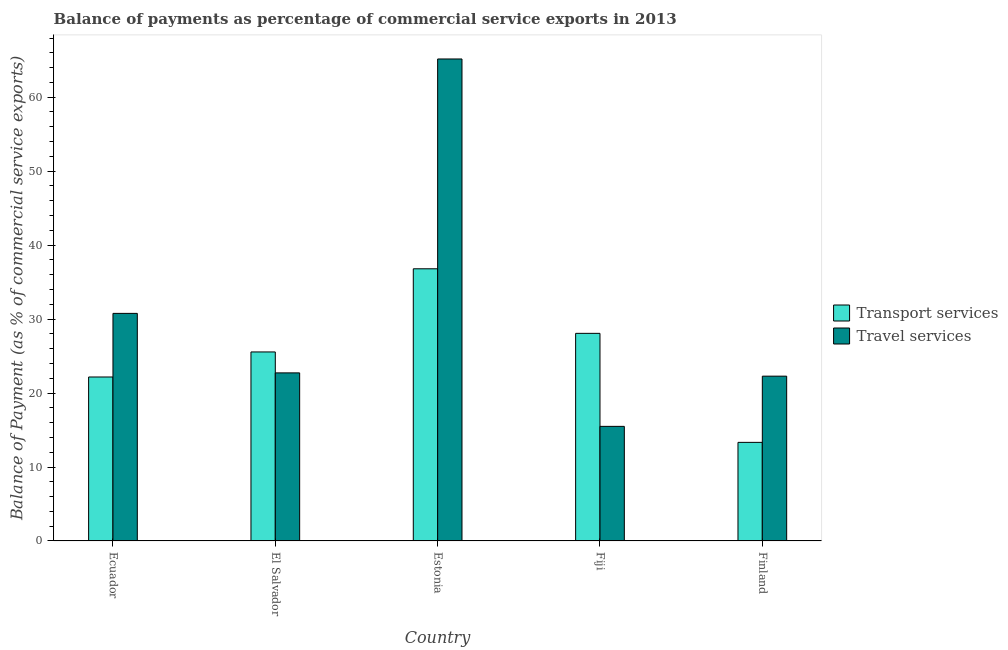How many different coloured bars are there?
Provide a short and direct response. 2. How many groups of bars are there?
Ensure brevity in your answer.  5. What is the label of the 2nd group of bars from the left?
Provide a short and direct response. El Salvador. In how many cases, is the number of bars for a given country not equal to the number of legend labels?
Offer a very short reply. 0. What is the balance of payments of travel services in Ecuador?
Make the answer very short. 30.77. Across all countries, what is the maximum balance of payments of travel services?
Keep it short and to the point. 65.16. Across all countries, what is the minimum balance of payments of travel services?
Your answer should be very brief. 15.49. In which country was the balance of payments of travel services maximum?
Offer a terse response. Estonia. In which country was the balance of payments of travel services minimum?
Your answer should be very brief. Fiji. What is the total balance of payments of transport services in the graph?
Provide a succinct answer. 125.93. What is the difference between the balance of payments of travel services in El Salvador and that in Estonia?
Your answer should be very brief. -42.44. What is the difference between the balance of payments of transport services in El Salvador and the balance of payments of travel services in Finland?
Your answer should be very brief. 3.27. What is the average balance of payments of transport services per country?
Keep it short and to the point. 25.19. What is the difference between the balance of payments of travel services and balance of payments of transport services in Fiji?
Your answer should be very brief. -12.57. In how many countries, is the balance of payments of transport services greater than 46 %?
Make the answer very short. 0. What is the ratio of the balance of payments of travel services in El Salvador to that in Fiji?
Your answer should be very brief. 1.47. What is the difference between the highest and the second highest balance of payments of travel services?
Offer a very short reply. 34.39. What is the difference between the highest and the lowest balance of payments of transport services?
Offer a very short reply. 23.47. In how many countries, is the balance of payments of transport services greater than the average balance of payments of transport services taken over all countries?
Give a very brief answer. 3. Is the sum of the balance of payments of travel services in Estonia and Finland greater than the maximum balance of payments of transport services across all countries?
Provide a succinct answer. Yes. What does the 1st bar from the left in Estonia represents?
Your answer should be compact. Transport services. What does the 1st bar from the right in Estonia represents?
Ensure brevity in your answer.  Travel services. How many bars are there?
Ensure brevity in your answer.  10. Are all the bars in the graph horizontal?
Ensure brevity in your answer.  No. Does the graph contain grids?
Offer a terse response. No. Where does the legend appear in the graph?
Provide a succinct answer. Center right. How many legend labels are there?
Ensure brevity in your answer.  2. How are the legend labels stacked?
Provide a succinct answer. Vertical. What is the title of the graph?
Offer a terse response. Balance of payments as percentage of commercial service exports in 2013. Does "Commercial bank branches" appear as one of the legend labels in the graph?
Keep it short and to the point. No. What is the label or title of the X-axis?
Ensure brevity in your answer.  Country. What is the label or title of the Y-axis?
Give a very brief answer. Balance of Payment (as % of commercial service exports). What is the Balance of Payment (as % of commercial service exports) in Transport services in Ecuador?
Offer a terse response. 22.17. What is the Balance of Payment (as % of commercial service exports) in Travel services in Ecuador?
Your answer should be very brief. 30.77. What is the Balance of Payment (as % of commercial service exports) of Transport services in El Salvador?
Offer a terse response. 25.56. What is the Balance of Payment (as % of commercial service exports) in Travel services in El Salvador?
Your answer should be compact. 22.73. What is the Balance of Payment (as % of commercial service exports) of Transport services in Estonia?
Your answer should be very brief. 36.8. What is the Balance of Payment (as % of commercial service exports) in Travel services in Estonia?
Keep it short and to the point. 65.16. What is the Balance of Payment (as % of commercial service exports) of Transport services in Fiji?
Your response must be concise. 28.07. What is the Balance of Payment (as % of commercial service exports) in Travel services in Fiji?
Your answer should be compact. 15.49. What is the Balance of Payment (as % of commercial service exports) of Transport services in Finland?
Ensure brevity in your answer.  13.33. What is the Balance of Payment (as % of commercial service exports) in Travel services in Finland?
Provide a short and direct response. 22.28. Across all countries, what is the maximum Balance of Payment (as % of commercial service exports) of Transport services?
Keep it short and to the point. 36.8. Across all countries, what is the maximum Balance of Payment (as % of commercial service exports) of Travel services?
Your response must be concise. 65.16. Across all countries, what is the minimum Balance of Payment (as % of commercial service exports) in Transport services?
Make the answer very short. 13.33. Across all countries, what is the minimum Balance of Payment (as % of commercial service exports) in Travel services?
Make the answer very short. 15.49. What is the total Balance of Payment (as % of commercial service exports) of Transport services in the graph?
Your answer should be very brief. 125.93. What is the total Balance of Payment (as % of commercial service exports) in Travel services in the graph?
Provide a short and direct response. 156.44. What is the difference between the Balance of Payment (as % of commercial service exports) in Transport services in Ecuador and that in El Salvador?
Provide a succinct answer. -3.39. What is the difference between the Balance of Payment (as % of commercial service exports) of Travel services in Ecuador and that in El Salvador?
Offer a terse response. 8.04. What is the difference between the Balance of Payment (as % of commercial service exports) in Transport services in Ecuador and that in Estonia?
Your answer should be very brief. -14.63. What is the difference between the Balance of Payment (as % of commercial service exports) in Travel services in Ecuador and that in Estonia?
Give a very brief answer. -34.39. What is the difference between the Balance of Payment (as % of commercial service exports) in Transport services in Ecuador and that in Fiji?
Offer a very short reply. -5.9. What is the difference between the Balance of Payment (as % of commercial service exports) of Travel services in Ecuador and that in Fiji?
Give a very brief answer. 15.28. What is the difference between the Balance of Payment (as % of commercial service exports) in Transport services in Ecuador and that in Finland?
Your response must be concise. 8.84. What is the difference between the Balance of Payment (as % of commercial service exports) of Travel services in Ecuador and that in Finland?
Your answer should be compact. 8.49. What is the difference between the Balance of Payment (as % of commercial service exports) in Transport services in El Salvador and that in Estonia?
Your answer should be very brief. -11.24. What is the difference between the Balance of Payment (as % of commercial service exports) of Travel services in El Salvador and that in Estonia?
Give a very brief answer. -42.44. What is the difference between the Balance of Payment (as % of commercial service exports) in Transport services in El Salvador and that in Fiji?
Your answer should be very brief. -2.51. What is the difference between the Balance of Payment (as % of commercial service exports) in Travel services in El Salvador and that in Fiji?
Keep it short and to the point. 7.23. What is the difference between the Balance of Payment (as % of commercial service exports) in Transport services in El Salvador and that in Finland?
Offer a terse response. 12.22. What is the difference between the Balance of Payment (as % of commercial service exports) in Travel services in El Salvador and that in Finland?
Provide a short and direct response. 0.44. What is the difference between the Balance of Payment (as % of commercial service exports) of Transport services in Estonia and that in Fiji?
Provide a short and direct response. 8.73. What is the difference between the Balance of Payment (as % of commercial service exports) in Travel services in Estonia and that in Fiji?
Provide a succinct answer. 49.67. What is the difference between the Balance of Payment (as % of commercial service exports) of Transport services in Estonia and that in Finland?
Offer a terse response. 23.47. What is the difference between the Balance of Payment (as % of commercial service exports) of Travel services in Estonia and that in Finland?
Provide a succinct answer. 42.88. What is the difference between the Balance of Payment (as % of commercial service exports) in Transport services in Fiji and that in Finland?
Provide a succinct answer. 14.74. What is the difference between the Balance of Payment (as % of commercial service exports) of Travel services in Fiji and that in Finland?
Your answer should be very brief. -6.79. What is the difference between the Balance of Payment (as % of commercial service exports) in Transport services in Ecuador and the Balance of Payment (as % of commercial service exports) in Travel services in El Salvador?
Your answer should be very brief. -0.56. What is the difference between the Balance of Payment (as % of commercial service exports) of Transport services in Ecuador and the Balance of Payment (as % of commercial service exports) of Travel services in Estonia?
Keep it short and to the point. -42.99. What is the difference between the Balance of Payment (as % of commercial service exports) in Transport services in Ecuador and the Balance of Payment (as % of commercial service exports) in Travel services in Fiji?
Offer a very short reply. 6.68. What is the difference between the Balance of Payment (as % of commercial service exports) of Transport services in Ecuador and the Balance of Payment (as % of commercial service exports) of Travel services in Finland?
Make the answer very short. -0.11. What is the difference between the Balance of Payment (as % of commercial service exports) in Transport services in El Salvador and the Balance of Payment (as % of commercial service exports) in Travel services in Estonia?
Your answer should be very brief. -39.61. What is the difference between the Balance of Payment (as % of commercial service exports) of Transport services in El Salvador and the Balance of Payment (as % of commercial service exports) of Travel services in Fiji?
Provide a succinct answer. 10.06. What is the difference between the Balance of Payment (as % of commercial service exports) of Transport services in El Salvador and the Balance of Payment (as % of commercial service exports) of Travel services in Finland?
Ensure brevity in your answer.  3.27. What is the difference between the Balance of Payment (as % of commercial service exports) of Transport services in Estonia and the Balance of Payment (as % of commercial service exports) of Travel services in Fiji?
Your answer should be compact. 21.3. What is the difference between the Balance of Payment (as % of commercial service exports) of Transport services in Estonia and the Balance of Payment (as % of commercial service exports) of Travel services in Finland?
Your answer should be compact. 14.52. What is the difference between the Balance of Payment (as % of commercial service exports) in Transport services in Fiji and the Balance of Payment (as % of commercial service exports) in Travel services in Finland?
Provide a succinct answer. 5.79. What is the average Balance of Payment (as % of commercial service exports) of Transport services per country?
Keep it short and to the point. 25.18. What is the average Balance of Payment (as % of commercial service exports) in Travel services per country?
Your response must be concise. 31.29. What is the difference between the Balance of Payment (as % of commercial service exports) in Transport services and Balance of Payment (as % of commercial service exports) in Travel services in Ecuador?
Ensure brevity in your answer.  -8.6. What is the difference between the Balance of Payment (as % of commercial service exports) in Transport services and Balance of Payment (as % of commercial service exports) in Travel services in El Salvador?
Provide a succinct answer. 2.83. What is the difference between the Balance of Payment (as % of commercial service exports) in Transport services and Balance of Payment (as % of commercial service exports) in Travel services in Estonia?
Provide a succinct answer. -28.37. What is the difference between the Balance of Payment (as % of commercial service exports) of Transport services and Balance of Payment (as % of commercial service exports) of Travel services in Fiji?
Keep it short and to the point. 12.57. What is the difference between the Balance of Payment (as % of commercial service exports) of Transport services and Balance of Payment (as % of commercial service exports) of Travel services in Finland?
Ensure brevity in your answer.  -8.95. What is the ratio of the Balance of Payment (as % of commercial service exports) in Transport services in Ecuador to that in El Salvador?
Give a very brief answer. 0.87. What is the ratio of the Balance of Payment (as % of commercial service exports) in Travel services in Ecuador to that in El Salvador?
Give a very brief answer. 1.35. What is the ratio of the Balance of Payment (as % of commercial service exports) of Transport services in Ecuador to that in Estonia?
Make the answer very short. 0.6. What is the ratio of the Balance of Payment (as % of commercial service exports) of Travel services in Ecuador to that in Estonia?
Provide a short and direct response. 0.47. What is the ratio of the Balance of Payment (as % of commercial service exports) in Transport services in Ecuador to that in Fiji?
Provide a short and direct response. 0.79. What is the ratio of the Balance of Payment (as % of commercial service exports) of Travel services in Ecuador to that in Fiji?
Your answer should be compact. 1.99. What is the ratio of the Balance of Payment (as % of commercial service exports) of Transport services in Ecuador to that in Finland?
Provide a succinct answer. 1.66. What is the ratio of the Balance of Payment (as % of commercial service exports) in Travel services in Ecuador to that in Finland?
Your response must be concise. 1.38. What is the ratio of the Balance of Payment (as % of commercial service exports) in Transport services in El Salvador to that in Estonia?
Make the answer very short. 0.69. What is the ratio of the Balance of Payment (as % of commercial service exports) of Travel services in El Salvador to that in Estonia?
Keep it short and to the point. 0.35. What is the ratio of the Balance of Payment (as % of commercial service exports) in Transport services in El Salvador to that in Fiji?
Your response must be concise. 0.91. What is the ratio of the Balance of Payment (as % of commercial service exports) of Travel services in El Salvador to that in Fiji?
Offer a very short reply. 1.47. What is the ratio of the Balance of Payment (as % of commercial service exports) of Transport services in El Salvador to that in Finland?
Give a very brief answer. 1.92. What is the ratio of the Balance of Payment (as % of commercial service exports) in Travel services in El Salvador to that in Finland?
Provide a short and direct response. 1.02. What is the ratio of the Balance of Payment (as % of commercial service exports) in Transport services in Estonia to that in Fiji?
Offer a very short reply. 1.31. What is the ratio of the Balance of Payment (as % of commercial service exports) in Travel services in Estonia to that in Fiji?
Your answer should be very brief. 4.21. What is the ratio of the Balance of Payment (as % of commercial service exports) of Transport services in Estonia to that in Finland?
Your answer should be very brief. 2.76. What is the ratio of the Balance of Payment (as % of commercial service exports) in Travel services in Estonia to that in Finland?
Your answer should be compact. 2.92. What is the ratio of the Balance of Payment (as % of commercial service exports) in Transport services in Fiji to that in Finland?
Keep it short and to the point. 2.11. What is the ratio of the Balance of Payment (as % of commercial service exports) in Travel services in Fiji to that in Finland?
Your answer should be compact. 0.7. What is the difference between the highest and the second highest Balance of Payment (as % of commercial service exports) of Transport services?
Provide a short and direct response. 8.73. What is the difference between the highest and the second highest Balance of Payment (as % of commercial service exports) in Travel services?
Offer a very short reply. 34.39. What is the difference between the highest and the lowest Balance of Payment (as % of commercial service exports) in Transport services?
Make the answer very short. 23.47. What is the difference between the highest and the lowest Balance of Payment (as % of commercial service exports) of Travel services?
Keep it short and to the point. 49.67. 